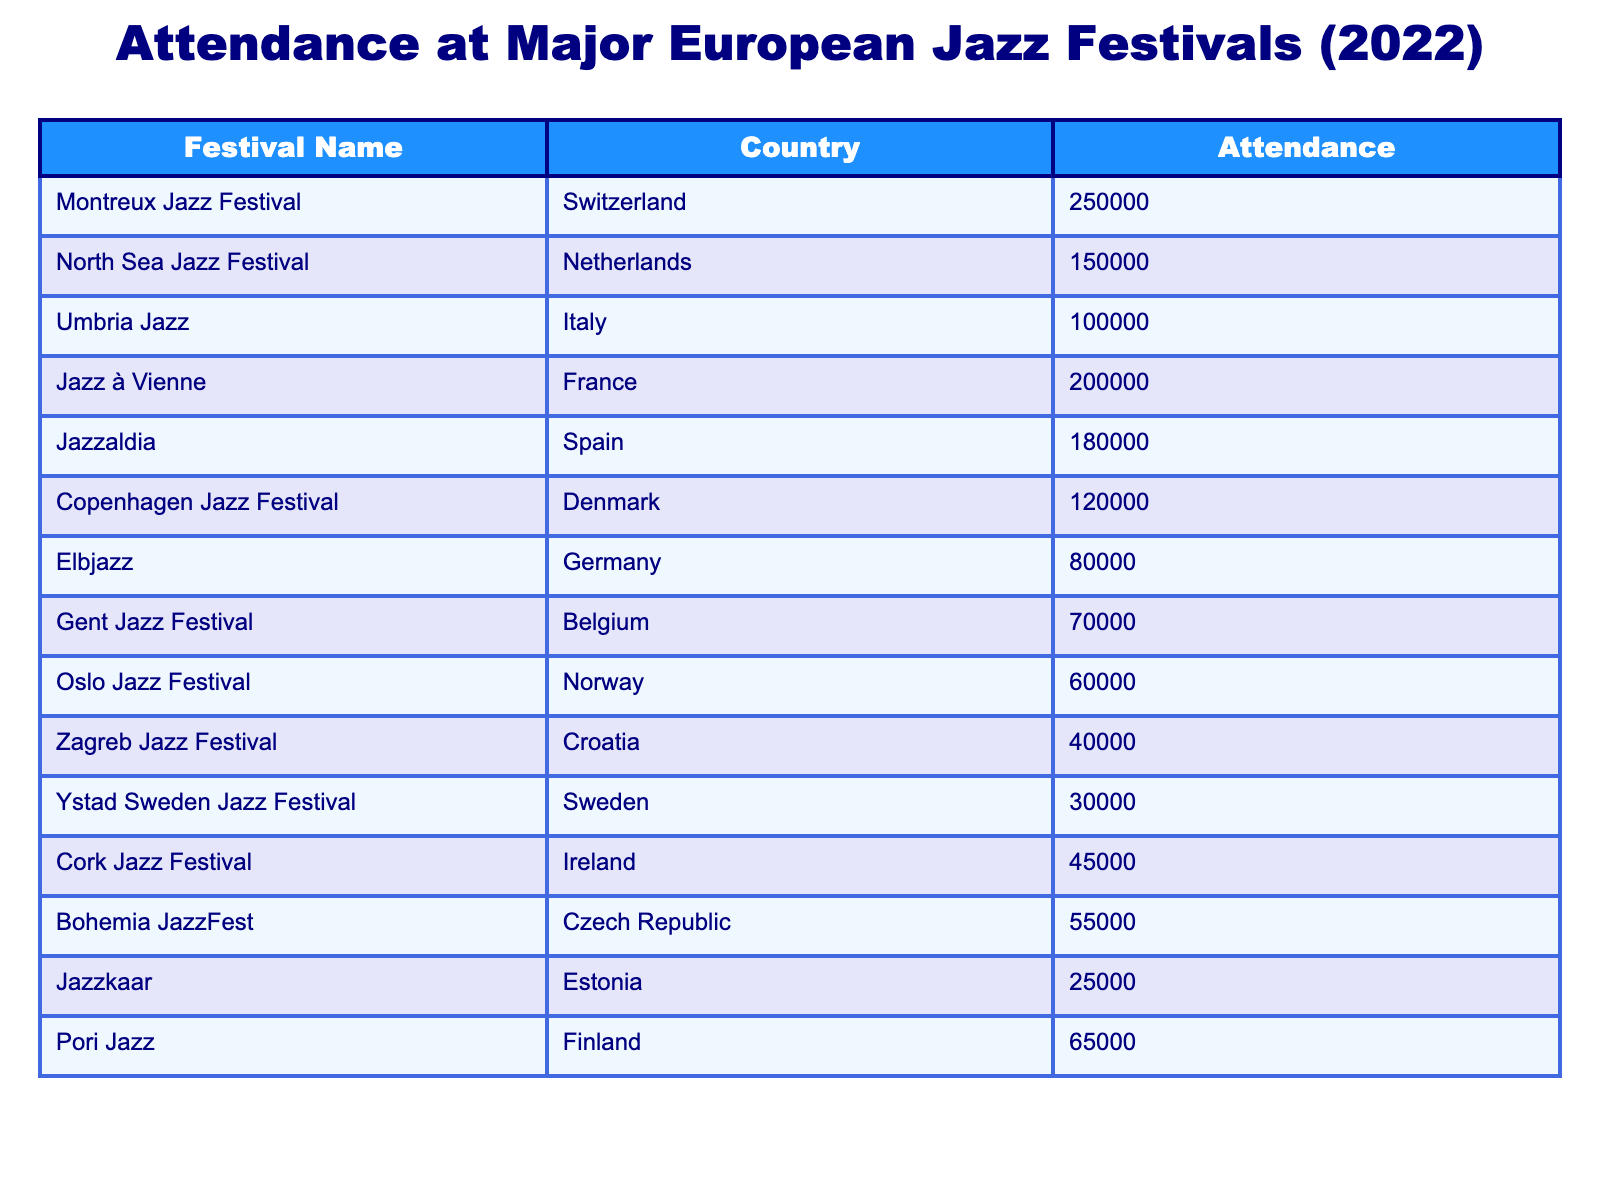What is the highest attendance at a jazz festival in the table? The table lists the attendance numbers for each festival, and the maximum attendance is 250,000 at the Montreux Jazz Festival in Switzerland.
Answer: 250,000 Which country hosted the festival with the lowest attendance? Oslo Jazz Festival in Norway has the lowest attendance at 60,000, which is less than any other festival listed.
Answer: Norway What is the total attendance for the festivals held in Italy and France? We take the attendance of Umbria Jazz (100,000) and Jazz à Vienne (200,000) and sum them: 100,000 + 200,000 = 300,000.
Answer: 300,000 Is the attendance for Copenhagen Jazz Festival greater than that of the Cork Jazz Festival? Copenhagen Jazz Festival has an attendance of 120,000, while Cork Jazz Festival has 45,000; since 120,000 is greater than 45,000, the statement is true.
Answer: Yes What is the average attendance across all the festivals listed in the table? The total attendance for all festivals is 1,365,000, and there are 14 festivals, so the average is 1,365,000 / 14 = 97,500.
Answer: 97,500 Which festival had an attendance above the average? The average attendance calculated is 97,500. The festivals above this attendance are Montreux Jazz Festival (250,000), North Sea Jazz Festival (150,000), Jazz à Vienne (200,000), and Jazzaldia (180,000).
Answer: Montreux Jazz Festival, North Sea Jazz Festival, Jazz à Vienne, Jazzaldia How many festivals had an attendance of more than 100,000? The festivals with attendance greater than 100,000 are Montreux Jazz Festival (250,000), North Sea Jazz Festival (150,000), Jazz à Vienne (200,000), and Jazzaldia (180,000). That's a total of 4 festivals.
Answer: 4 What is the difference in attendance between the festival with the highest and the one with the lowest? The highest attendance is 250,000 (Montreux Jazz Festival) and the lowest is 30,000 (Ystad Sweden Jazz Festival). The difference is 250,000 - 30,000 = 220,000.
Answer: 220,000 Which country has the second highest festival attendance, and what is that attendance? The second highest attendance is 200,000, which corresponds to Jazz à Vienne in France. Therefore, the answer is France with an attendance of 200,000.
Answer: France, 200,000 What percentage of total attendance does the Elbjazz festival account for? Elbjazz has an attendance of 80,000. The total attendance is 1,365,000. The percentage is (80,000 / 1,365,000) * 100 = 5.86%.
Answer: 5.86% 